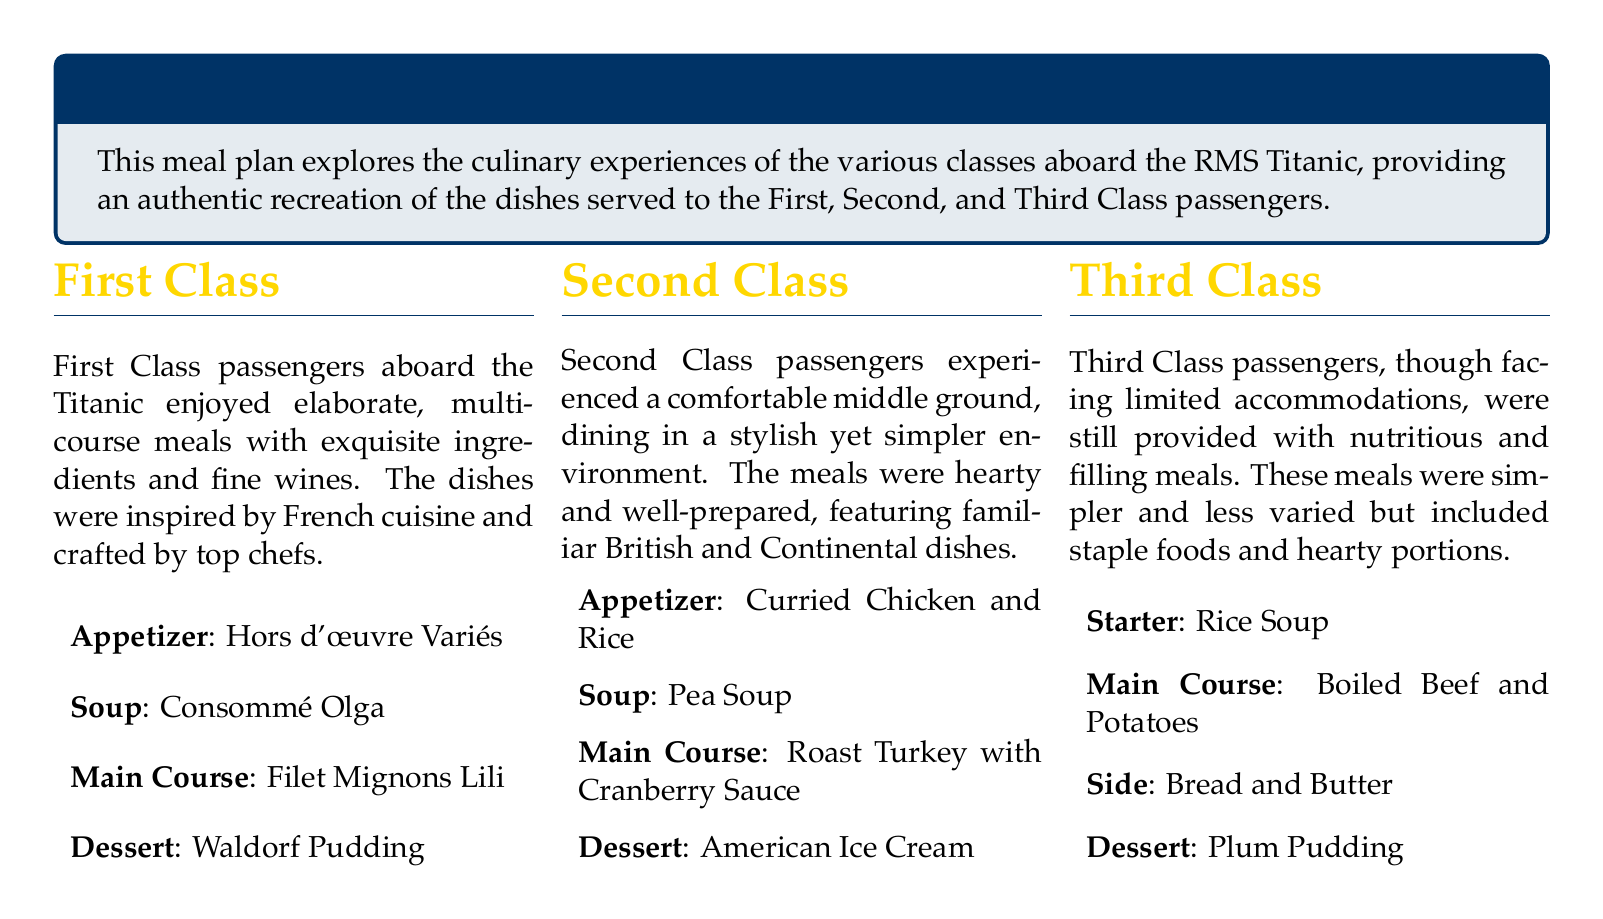What is the first appetizer on the First Class menu? The first appetizer listed under the First Class menu is "Hors d'œuvre Variés."
Answer: Hors d'œuvre Variés What type of soup is served in Second Class? The type of soup served in Second Class is "Pea Soup."
Answer: Pea Soup How many courses are typically experienced by First Class passengers? First Class passengers enjoyed multi-course meals, indicating more than one course, typically several.
Answer: Multi-course What is the main course for Third Class? The main course listed for Third Class passengers is "Boiled Beef and Potatoes."
Answer: Boiled Beef and Potatoes Which dessert is included in the First Class dining experience? The dessert included in the First Class dining experience is "Waldorf Pudding."
Answer: Waldorf Pudding What is the overall theme of the meal plan? The overall theme of the meal plan is based on the dining experiences of Titanic's passengers "First, Second, and Third Class."
Answer: Thematic Menu Based on Titanic's Passengers In which class is "American Ice Cream" served? "American Ice Cream" is served in the Second Class dining experience.
Answer: Second Class What dessert do Third Class passengers receive? The dessert provided to Third Class passengers is "Plum Pudding."
Answer: Plum Pudding What kind of cuisine inspired the First Class menu? The First Class menu is inspired by "French cuisine."
Answer: French cuisine 